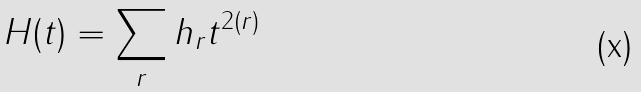Convert formula to latex. <formula><loc_0><loc_0><loc_500><loc_500>H ( t ) = \sum _ { r } h _ { r } t ^ { 2 ( r ) }</formula> 